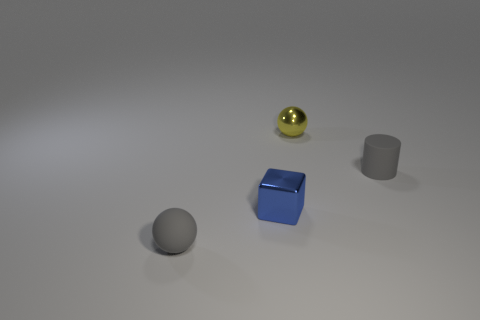Add 2 big yellow rubber cubes. How many objects exist? 6 Subtract 1 blocks. How many blocks are left? 0 Subtract all yellow spheres. How many spheres are left? 1 Subtract all cylinders. How many objects are left? 3 Subtract all purple balls. How many purple cylinders are left? 0 Subtract all small green things. Subtract all blue blocks. How many objects are left? 3 Add 2 tiny blue cubes. How many tiny blue cubes are left? 3 Add 4 gray spheres. How many gray spheres exist? 5 Subtract 1 yellow spheres. How many objects are left? 3 Subtract all purple blocks. Subtract all cyan balls. How many blocks are left? 1 